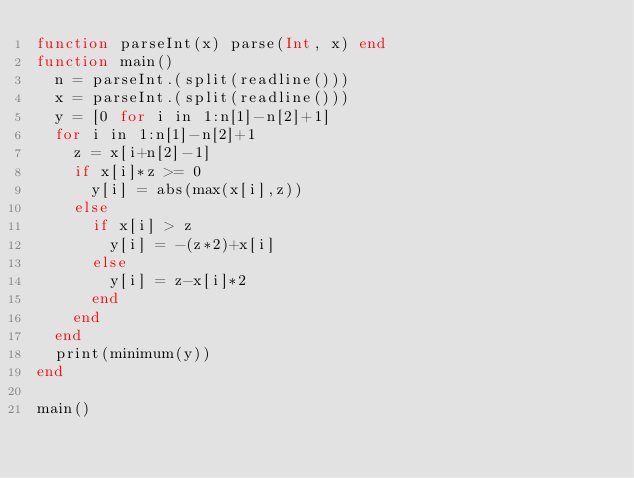<code> <loc_0><loc_0><loc_500><loc_500><_Julia_>function parseInt(x) parse(Int, x) end
function main()
  n = parseInt.(split(readline()))
  x = parseInt.(split(readline()))
  y = [0 for i in 1:n[1]-n[2]+1]
  for i in 1:n[1]-n[2]+1
    z = x[i+n[2]-1]
    if x[i]*z >= 0
      y[i] = abs(max(x[i],z))
    else
      if x[i] > z
        y[i] = -(z*2)+x[i]
      else
        y[i] = z-x[i]*2
      end
    end
  end
  print(minimum(y))
end

main()
</code> 